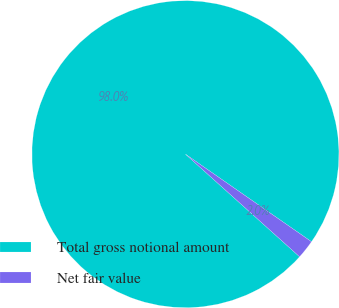Convert chart to OTSL. <chart><loc_0><loc_0><loc_500><loc_500><pie_chart><fcel>Total gross notional amount<fcel>Net fair value<nl><fcel>98.01%<fcel>1.99%<nl></chart> 